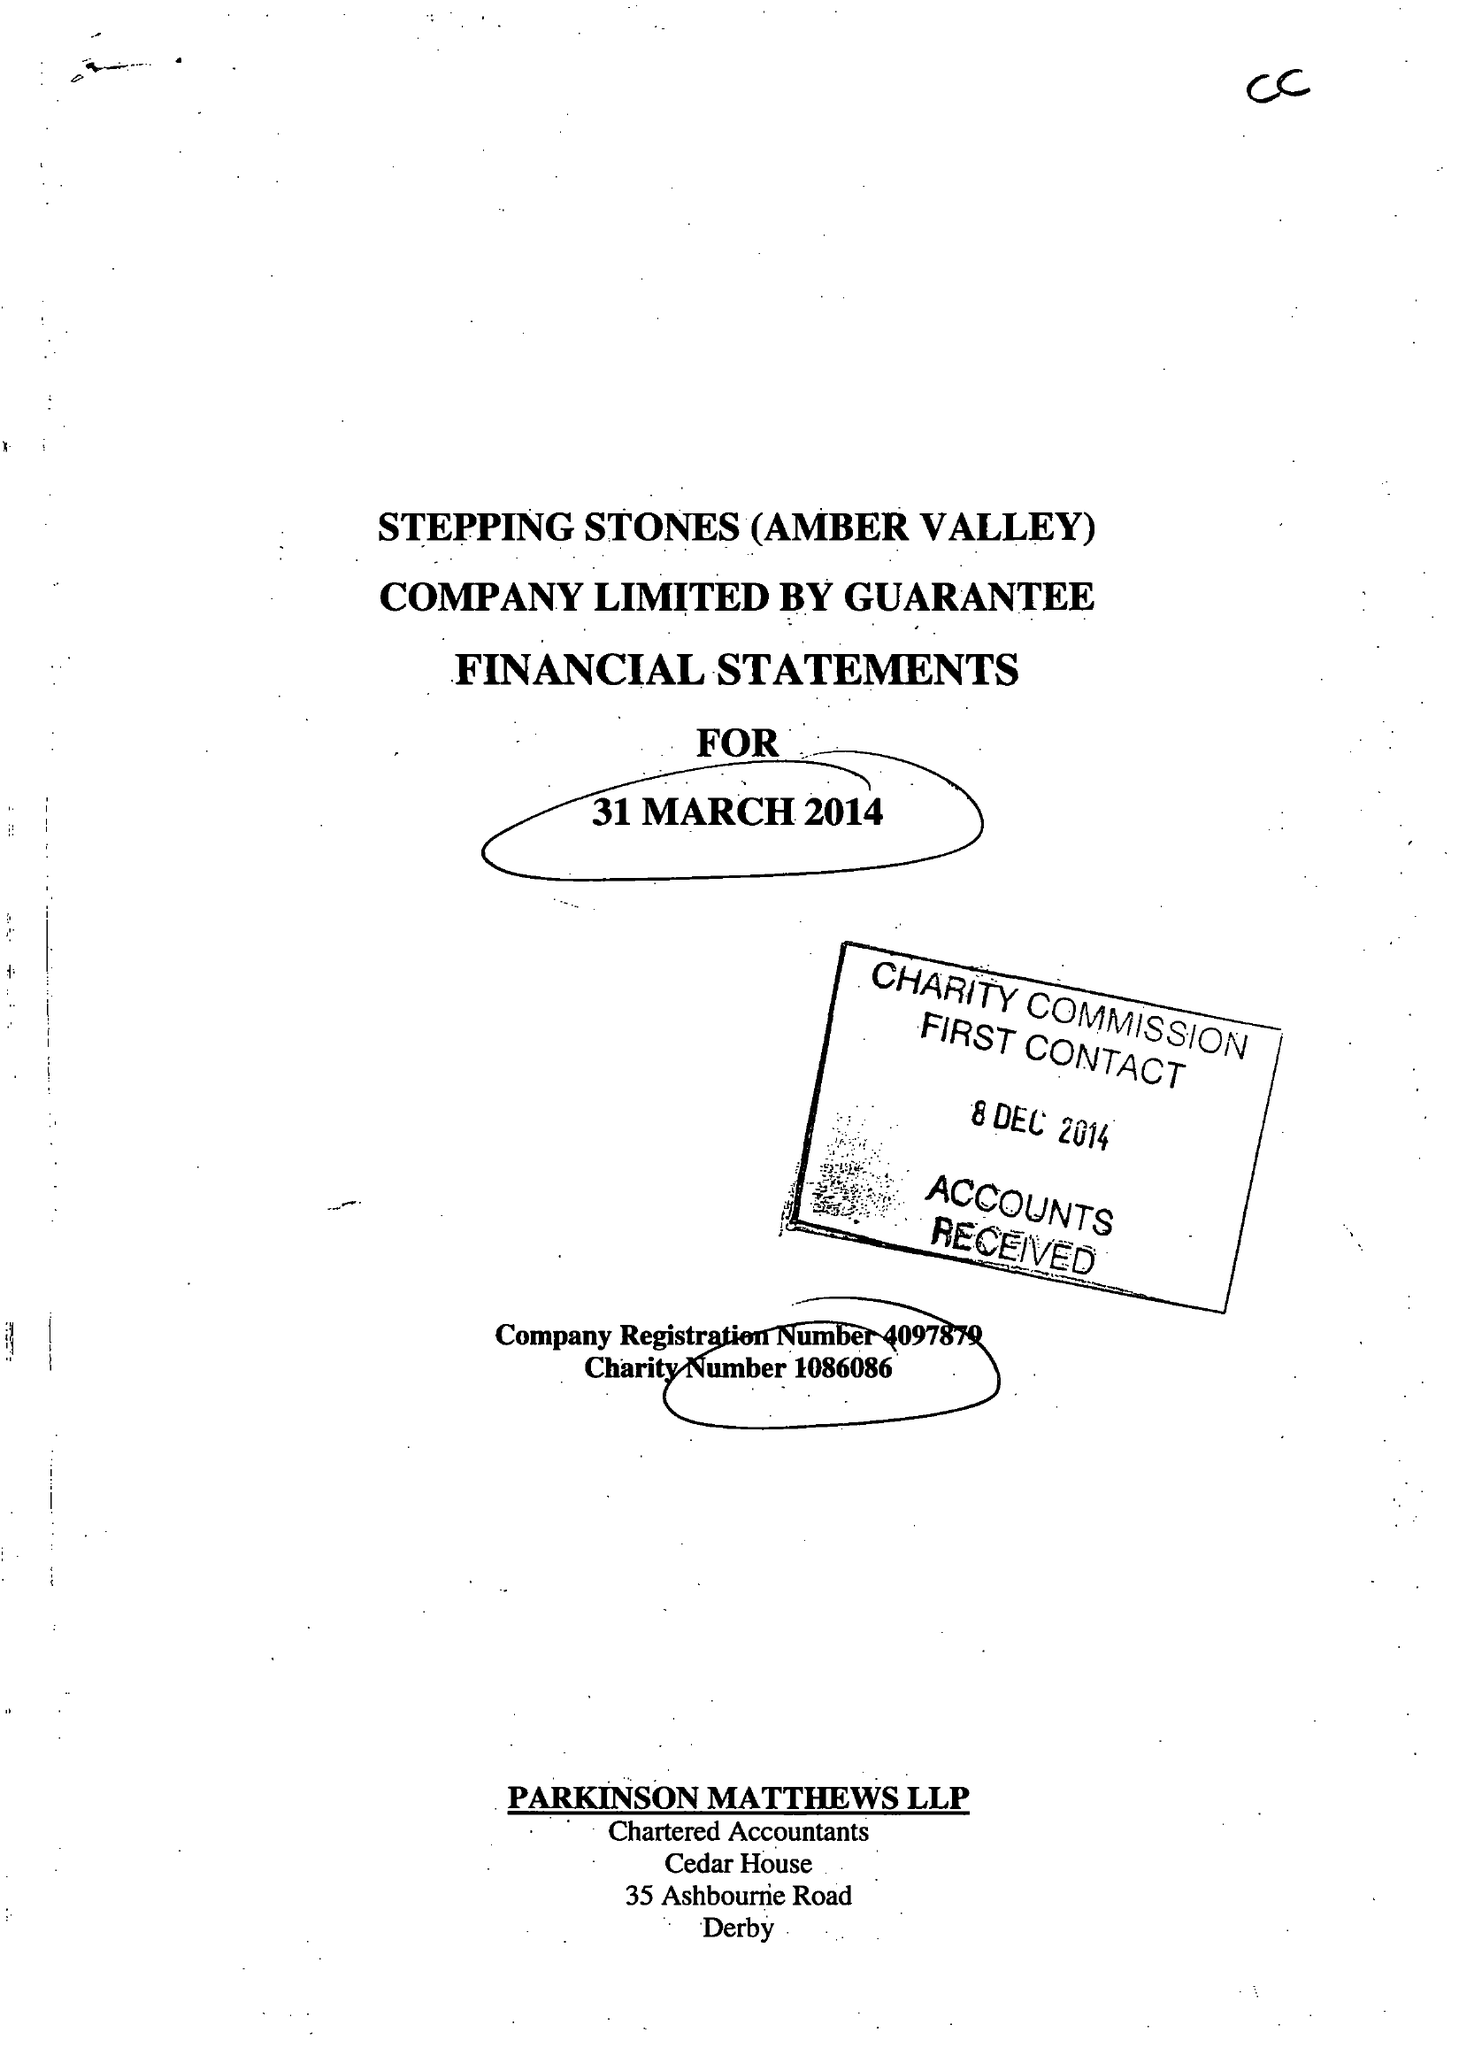What is the value for the address__street_line?
Answer the question using a single word or phrase. ILKESTON ROAD 